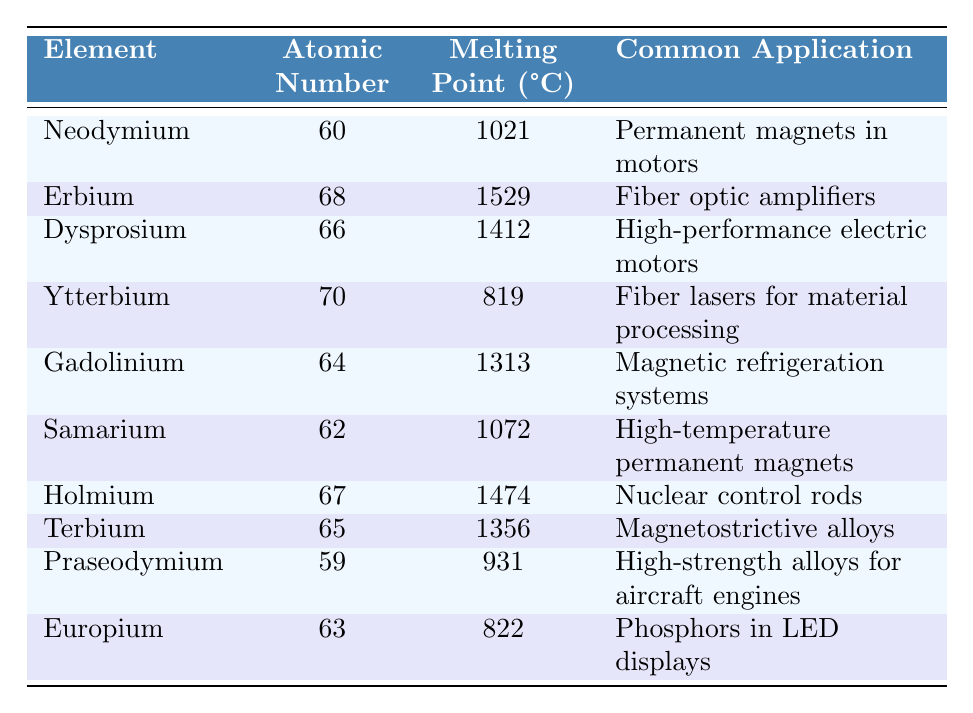What is the melting point of Neodymium? The table lists the melting point of Neodymium as 1021°C.
Answer: 1021°C Which element has the highest melting point? By reviewing the melting points in the table, Erbium has the highest melting point at 1529°C.
Answer: Erbium How many elements have a melting point above 1300°C? The melting points above 1300°C are those of Erbium, Dysprosium, Gadolinium, Holmium, and Terbium. This totals five elements.
Answer: 5 Is the melting point of Ytterbium higher than that of Europium? Ytterbium has a melting point of 819°C, while Europium's melting point is 822°C, so Ytterbium's melting point is not higher.
Answer: No What is the average melting point of the metals listed in the table? The total melting points are calculated as (1021 + 1529 + 1412 + 819 + 1313 + 1072 + 1474 + 1356 + 931 + 822) = 10219°C. There are 10 elements, so the average melting point is 10219/10 = 1021.9°C.
Answer: 1021.9°C Which element is commonly used in high-performance electric motors? The table indicates that Dysprosium is commonly used in high-performance electric motors.
Answer: Dysprosium What is the atomic number of the element used in fiber optic amplifiers? The table shows that Erbium is used in fiber optic amplifiers and has an atomic number of 68.
Answer: 68 List the elements that have a melting point below 900°C. The elements with melting points below 900°C are Ytterbium (819°C) and Europium (822°C).
Answer: Ytterbium, Europium How much higher is the melting point of Dysprosium compared to Neodymium? Dysprosium's melting point is 1412°C and Neodymium's is 1021°C. The difference is 1412 - 1021 = 391°C.
Answer: 391°C Which applications mention "magnets" in their usage? The applications mentioning "magnets" are Neodymium (permanent magnets in motors), Samarium (high-temperature permanent magnets), and Terbium (magnetostrictive alloys).
Answer: Neodymium, Samarium, Terbium 